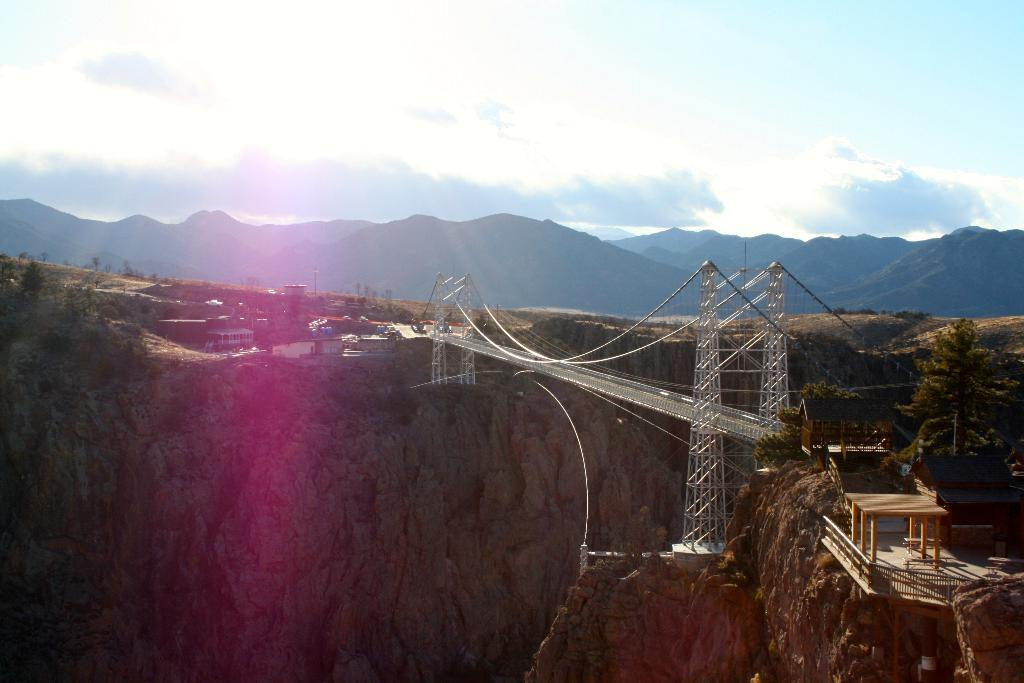What type of structure can be seen in the image? There is a bridge in the image. What other objects can be seen in the image? There is a table, a shed, a fence, houses, poles, and grass visible in the image. What is the terrain like in the image? There are hills in the image. What is visible in the sky? The sky is visible in the image, and there are clouds present. What type of record is being played on the table in the image? There is no record or table present in the image; the table is not mentioned in the facts. What type of suit is the person wearing while standing near the shed in the image? There is no person or suit present in the image; the facts do not mention any individuals or clothing. 